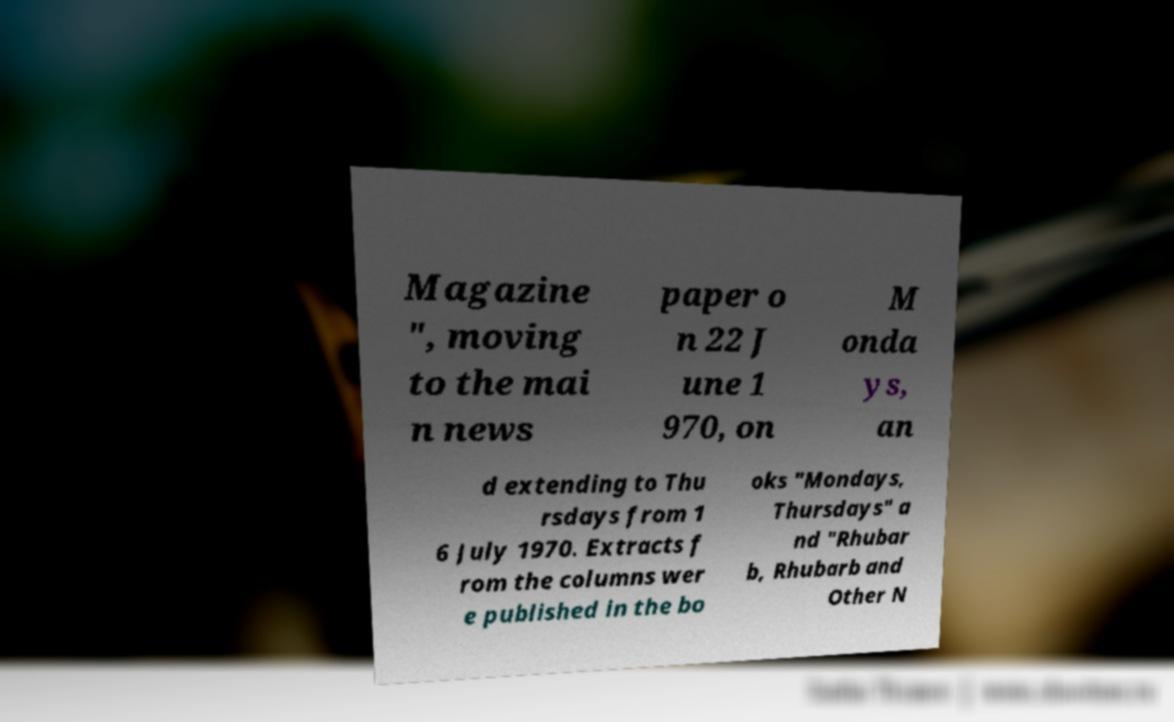Please identify and transcribe the text found in this image. Magazine ", moving to the mai n news paper o n 22 J une 1 970, on M onda ys, an d extending to Thu rsdays from 1 6 July 1970. Extracts f rom the columns wer e published in the bo oks "Mondays, Thursdays" a nd "Rhubar b, Rhubarb and Other N 